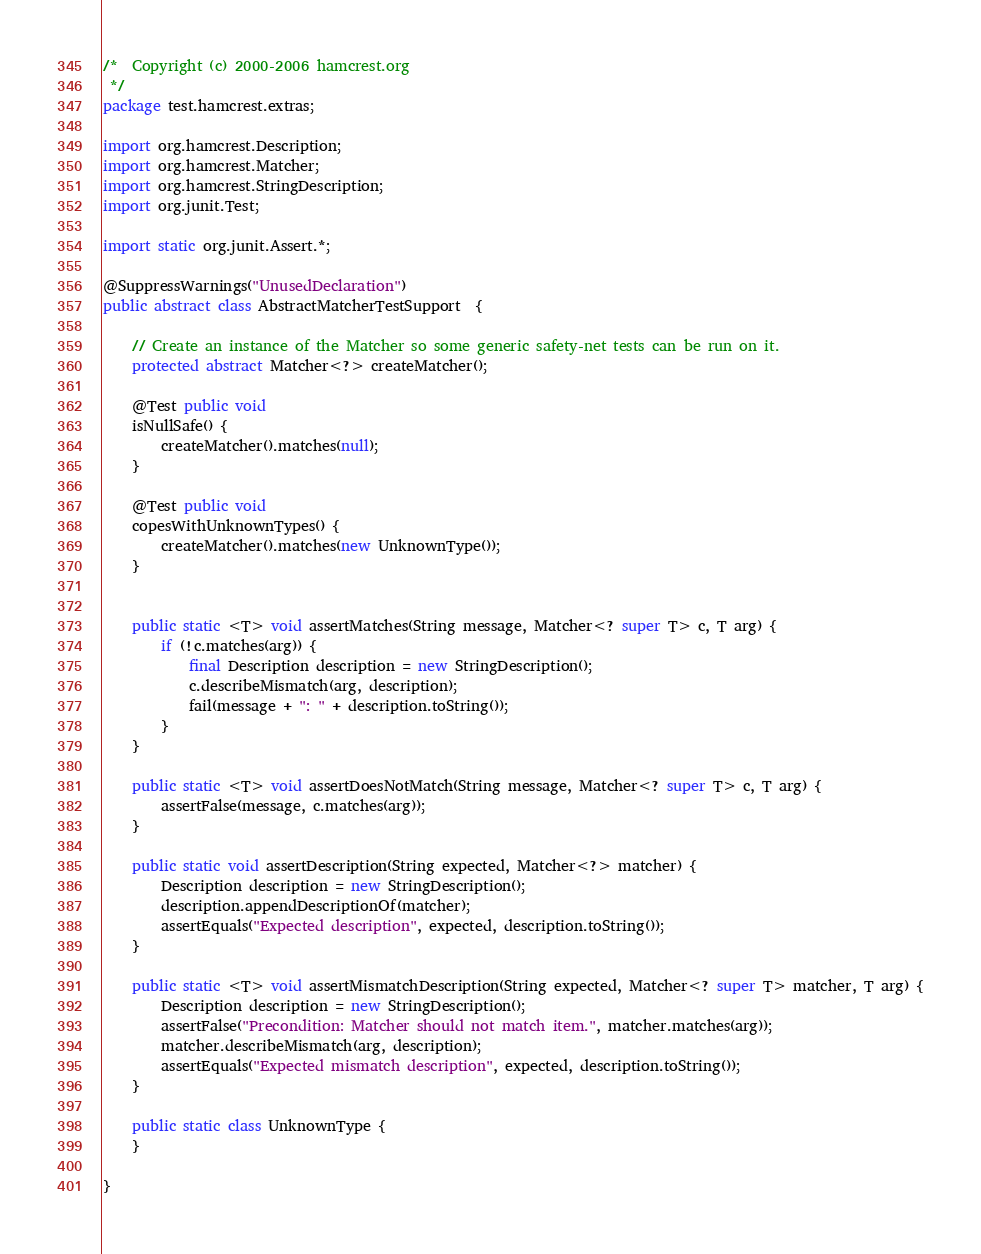Convert code to text. <code><loc_0><loc_0><loc_500><loc_500><_Java_>/*  Copyright (c) 2000-2006 hamcrest.org
 */
package test.hamcrest.extras;

import org.hamcrest.Description;
import org.hamcrest.Matcher;
import org.hamcrest.StringDescription;
import org.junit.Test;

import static org.junit.Assert.*;

@SuppressWarnings("UnusedDeclaration")
public abstract class AbstractMatcherTestSupport  {

    // Create an instance of the Matcher so some generic safety-net tests can be run on it.
    protected abstract Matcher<?> createMatcher();

    @Test public void
    isNullSafe() {
        createMatcher().matches(null);
    }

    @Test public void
    copesWithUnknownTypes() {
        createMatcher().matches(new UnknownType());
    }


    public static <T> void assertMatches(String message, Matcher<? super T> c, T arg) {
        if (!c.matches(arg)) {
            final Description description = new StringDescription();
            c.describeMismatch(arg, description);
            fail(message + ": " + description.toString());
        }
    }

    public static <T> void assertDoesNotMatch(String message, Matcher<? super T> c, T arg) {
        assertFalse(message, c.matches(arg));
    }

    public static void assertDescription(String expected, Matcher<?> matcher) {
        Description description = new StringDescription();
        description.appendDescriptionOf(matcher);
        assertEquals("Expected description", expected, description.toString());
    }

    public static <T> void assertMismatchDescription(String expected, Matcher<? super T> matcher, T arg) {
        Description description = new StringDescription();
        assertFalse("Precondition: Matcher should not match item.", matcher.matches(arg));
        matcher.describeMismatch(arg, description);
        assertEquals("Expected mismatch description", expected, description.toString());
    }

    public static class UnknownType {
    }

}
</code> 